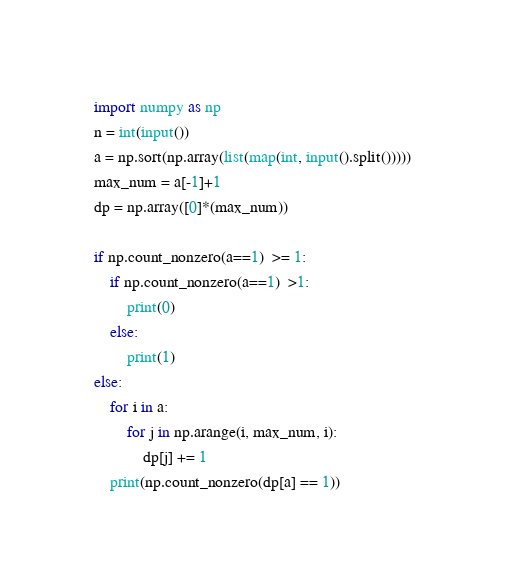Convert code to text. <code><loc_0><loc_0><loc_500><loc_500><_Python_>import numpy as np
n = int(input())
a = np.sort(np.array(list(map(int, input().split()))))
max_num = a[-1]+1
dp = np.array([0]*(max_num))

if np.count_nonzero(a==1)  >= 1:
    if np.count_nonzero(a==1)  >1:
        print(0)
    else:
        print(1)
else:
    for i in a:
        for j in np.arange(i, max_num, i):
            dp[j] += 1
    print(np.count_nonzero(dp[a] == 1))</code> 